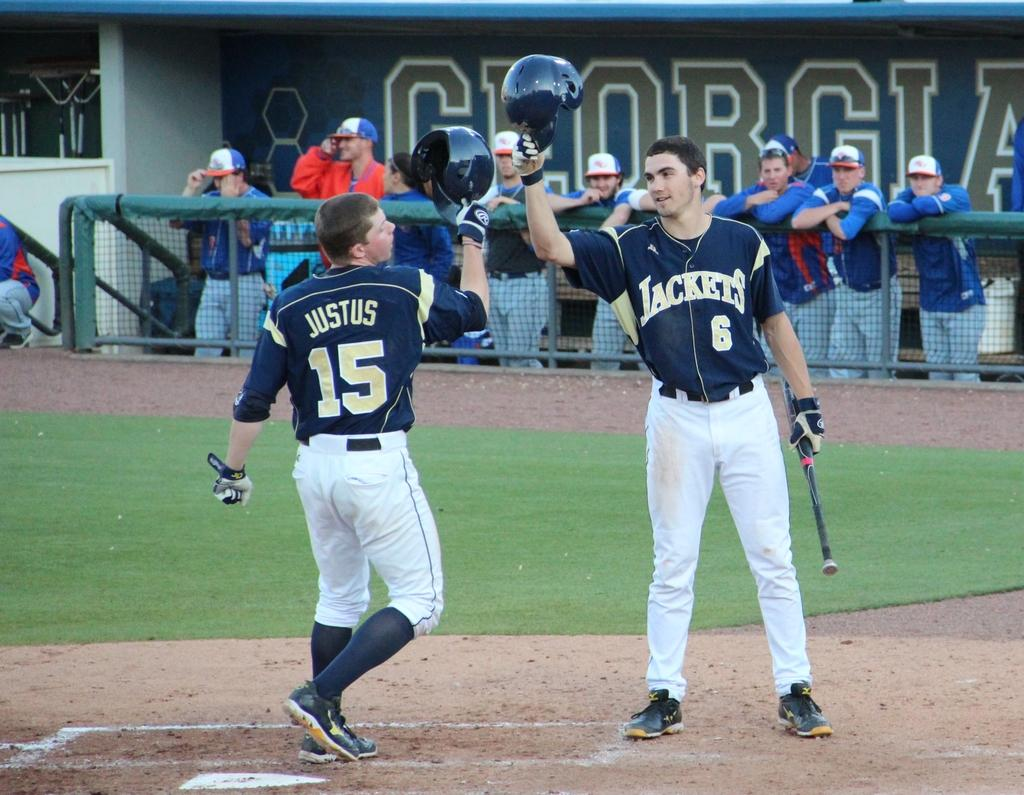<image>
Give a short and clear explanation of the subsequent image. georgia jackets players celebrating on the baseball field 